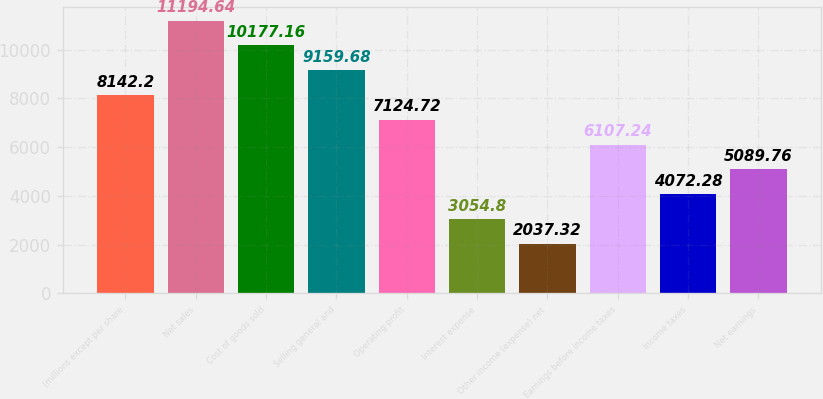<chart> <loc_0><loc_0><loc_500><loc_500><bar_chart><fcel>(millions except per share<fcel>Net sales<fcel>Cost of goods sold<fcel>Selling general and<fcel>Operating profit<fcel>Interest expense<fcel>Other income (expense) net<fcel>Earnings before income taxes<fcel>Income taxes<fcel>Net earnings<nl><fcel>8142.2<fcel>11194.6<fcel>10177.2<fcel>9159.68<fcel>7124.72<fcel>3054.8<fcel>2037.32<fcel>6107.24<fcel>4072.28<fcel>5089.76<nl></chart> 